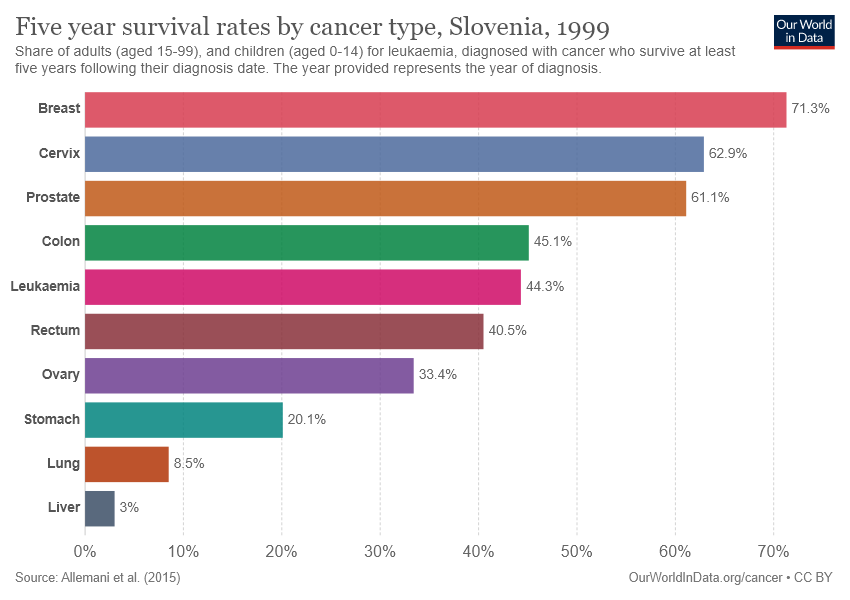List a handful of essential elements in this visual. The value of breast cancer is 8.4 and the value of cervical cancer is also 8.4. The bar graph depicts ten distinct types of cancer. 